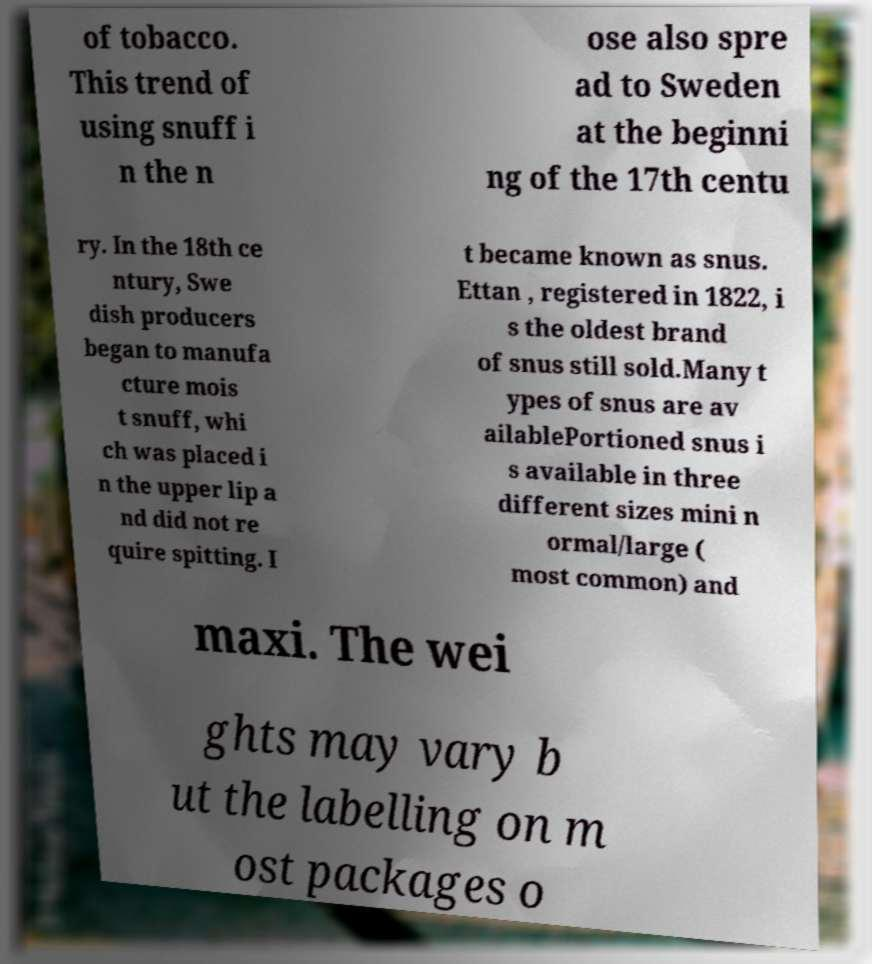I need the written content from this picture converted into text. Can you do that? of tobacco. This trend of using snuff i n the n ose also spre ad to Sweden at the beginni ng of the 17th centu ry. In the 18th ce ntury, Swe dish producers began to manufa cture mois t snuff, whi ch was placed i n the upper lip a nd did not re quire spitting. I t became known as snus. Ettan , registered in 1822, i s the oldest brand of snus still sold.Many t ypes of snus are av ailablePortioned snus i s available in three different sizes mini n ormal/large ( most common) and maxi. The wei ghts may vary b ut the labelling on m ost packages o 